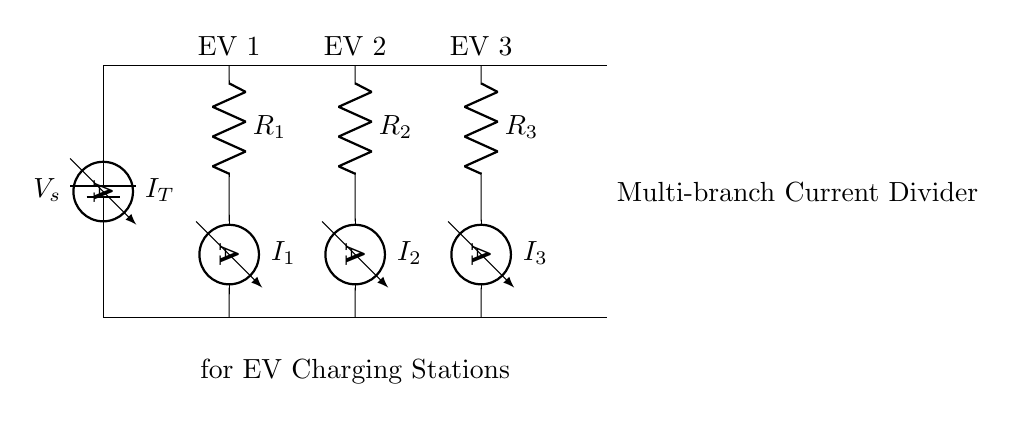What is the total current entering the current divider? The total current, represented by I_T, is the sum of the currents in all branches (I_1, I_2, I_3). The values of I_1, I_2, and I_3 would depend on the resistances R_1, R_2, and R_3.
Answer: I_T How many branches are there in the current divider? There are three branches in the current divider, each connected to a different EV charger (R_1, R_2, R_3).
Answer: Three What type of circuit is represented in the diagram? This is a multi-branch current divider circuit, as it distributes the total current among several parallel branches.
Answer: Current divider What is the current passing through EV Charger 1? The current through EV Charger 1 is denoted as I_1, which is determined by the resistance R_1 in relation to the total current I_T.
Answer: I_1 What is the relationship between the resistances and the currents in each branch? The current in each branch is inversely proportional to the resistance of that branch. Lower resistance leads to higher current, while higher resistance leads to lower current relative to the total current.
Answer: Inverse relationship Which branch has the highest current? The branch with the lowest resistance will have the highest current. Thus, it depends on the values of R_1, R_2, and R_3.
Answer: Lowest resistance branch What determines the amount of current each EV Charger receives? The amount of current each EV Charger receives is determined by the resistance values of each branch (R_1, R_2, R_3), which affect the current division according to Ohm's Law.
Answer: Resistance values 